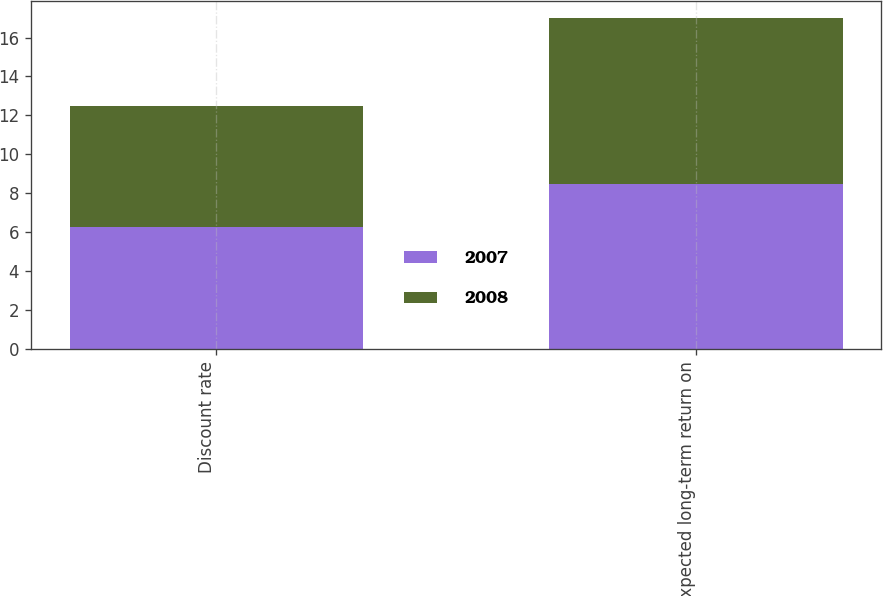Convert chart. <chart><loc_0><loc_0><loc_500><loc_500><stacked_bar_chart><ecel><fcel>Discount rate<fcel>Expected long-term return on<nl><fcel>2007<fcel>6.25<fcel>8.5<nl><fcel>2008<fcel>6.22<fcel>8.5<nl></chart> 